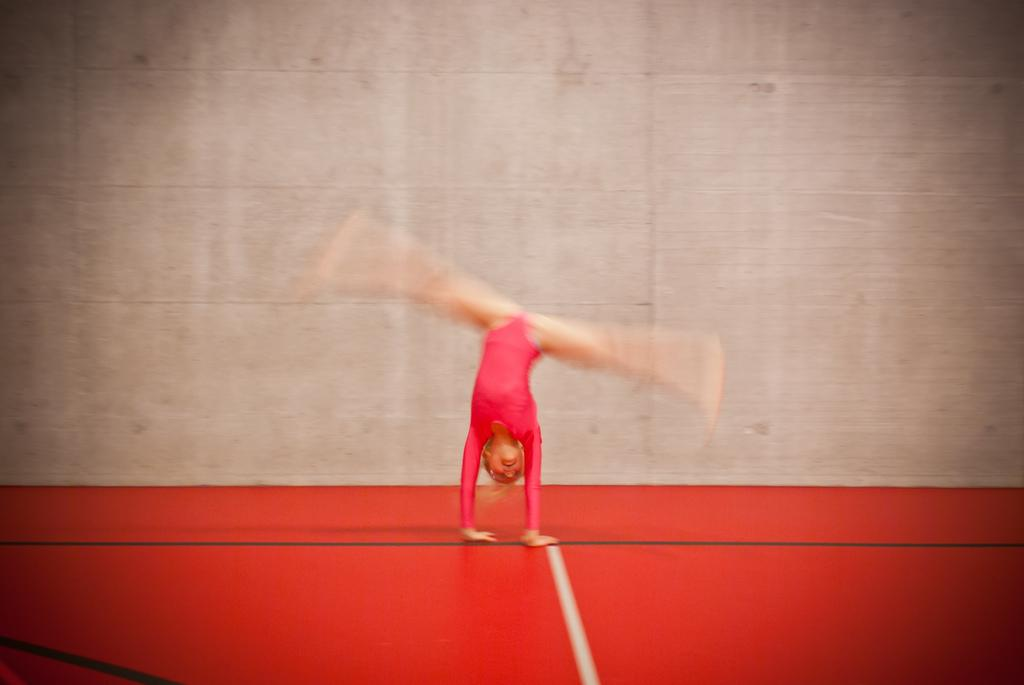Who is the main subject in the image? There is a girl in the image. What is the girl doing in the image? The girl is performing gymnastics. What is the girl standing on in the image? The girl is on a red mat. What can be seen in the background of the image? There is a wall in the background of the image. What type of crime is being committed in the image? There is no crime being committed in the image; it features a girl performing gymnastics on a red mat. How many grains of sand can be seen on the girl's leotard in the image? There is no sand present in the image, so it is not possible to determine the number of grains on the girl's leotard. 